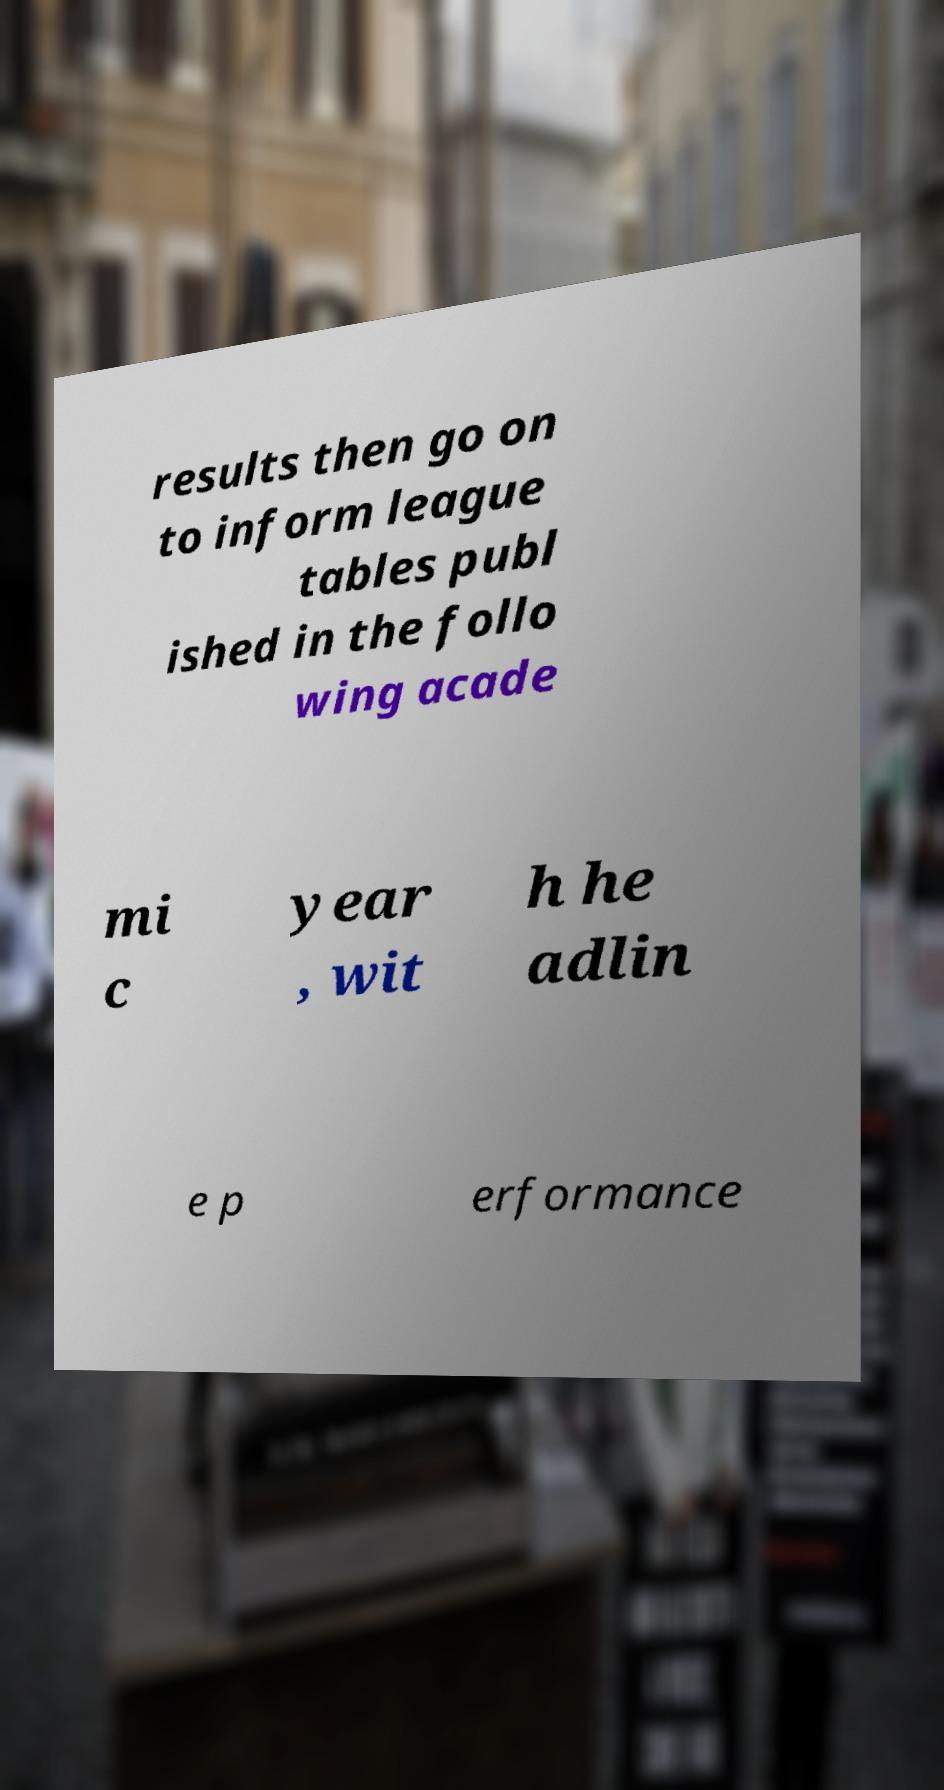There's text embedded in this image that I need extracted. Can you transcribe it verbatim? results then go on to inform league tables publ ished in the follo wing acade mi c year , wit h he adlin e p erformance 